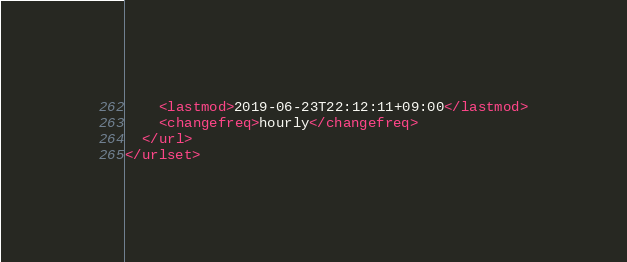Convert code to text. <code><loc_0><loc_0><loc_500><loc_500><_XML_>    <lastmod>2019-06-23T22:12:11+09:00</lastmod>
    <changefreq>hourly</changefreq>
  </url>
</urlset>
</code> 